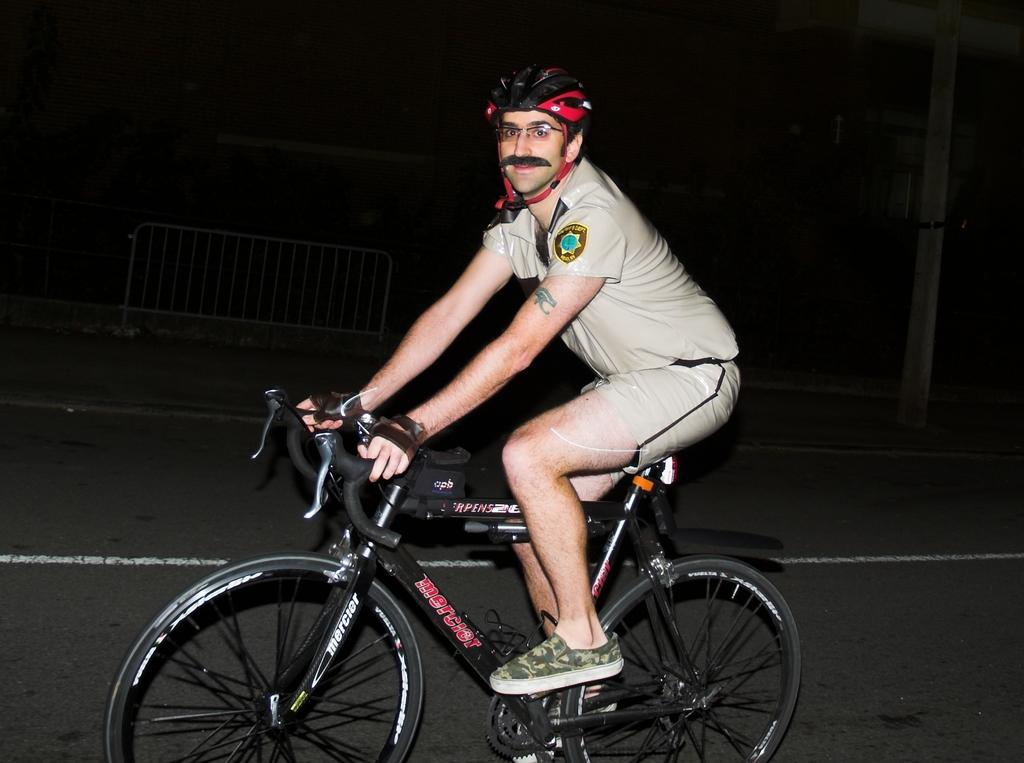Who is the person in the image? There is a man in the image. What is the man wearing on his upper body? The man is wearing a cream shirt. What type of headgear is the man wearing? The man is wearing a black and red color helmet. What is the man doing in the image? The man is riding a bicycle. Where is the man riding the bicycle? The bicycle is on a road. What can be seen near the road in the image? There are iron railings visible in the image. How would you describe the lighting conditions in the image? The image was taken in a dark environment. How many cars can be seen in the image? There are no cars visible in the image; it features a man riding a bicycle. What achievement is the man celebrating in the image? There is no indication of any achievement being celebrated in the image; the man is simply riding a bicycle. 